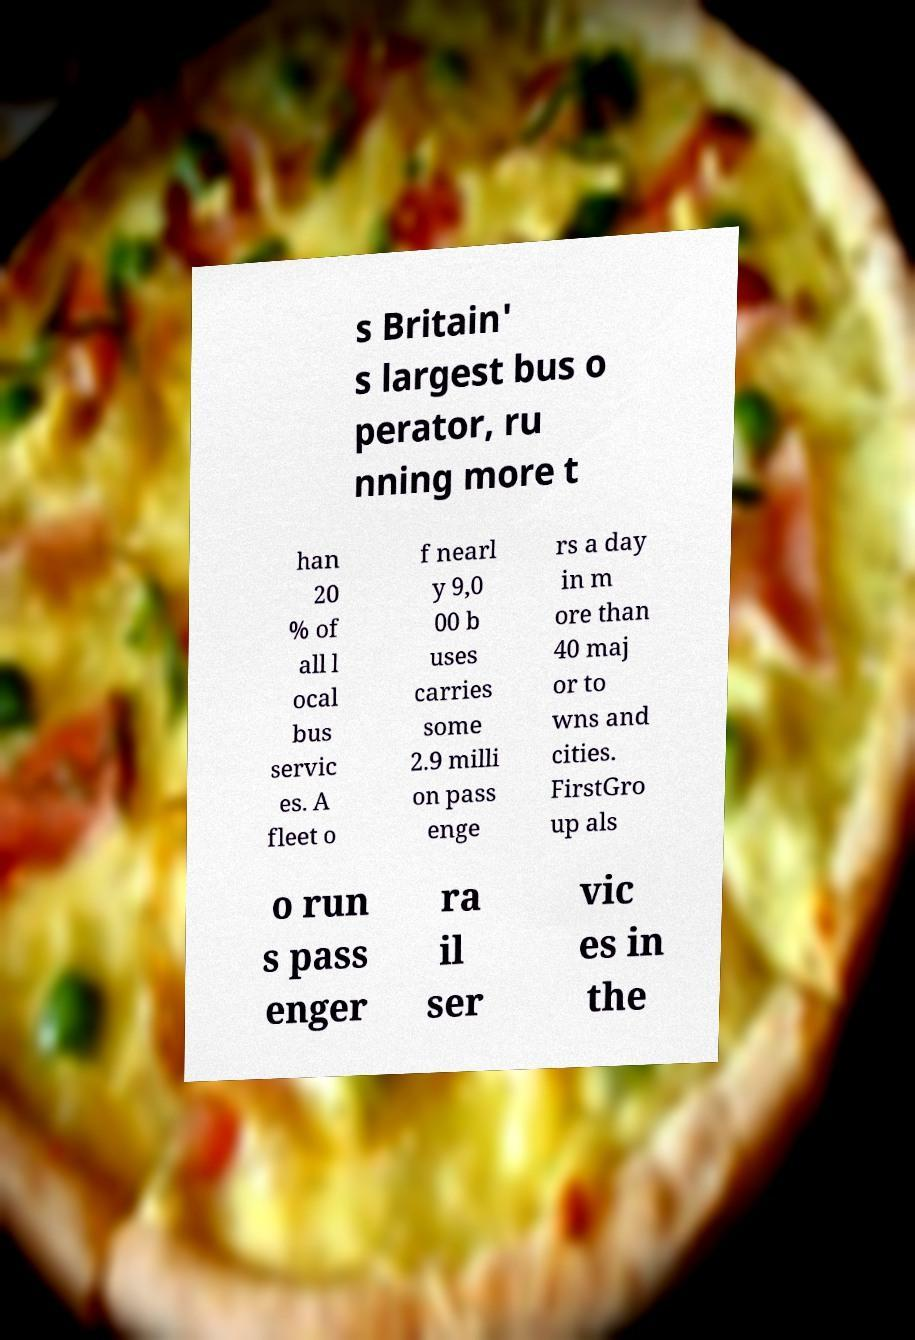Please identify and transcribe the text found in this image. s Britain' s largest bus o perator, ru nning more t han 20 % of all l ocal bus servic es. A fleet o f nearl y 9,0 00 b uses carries some 2.9 milli on pass enge rs a day in m ore than 40 maj or to wns and cities. FirstGro up als o run s pass enger ra il ser vic es in the 